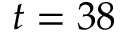Convert formula to latex. <formula><loc_0><loc_0><loc_500><loc_500>t = 3 8</formula> 